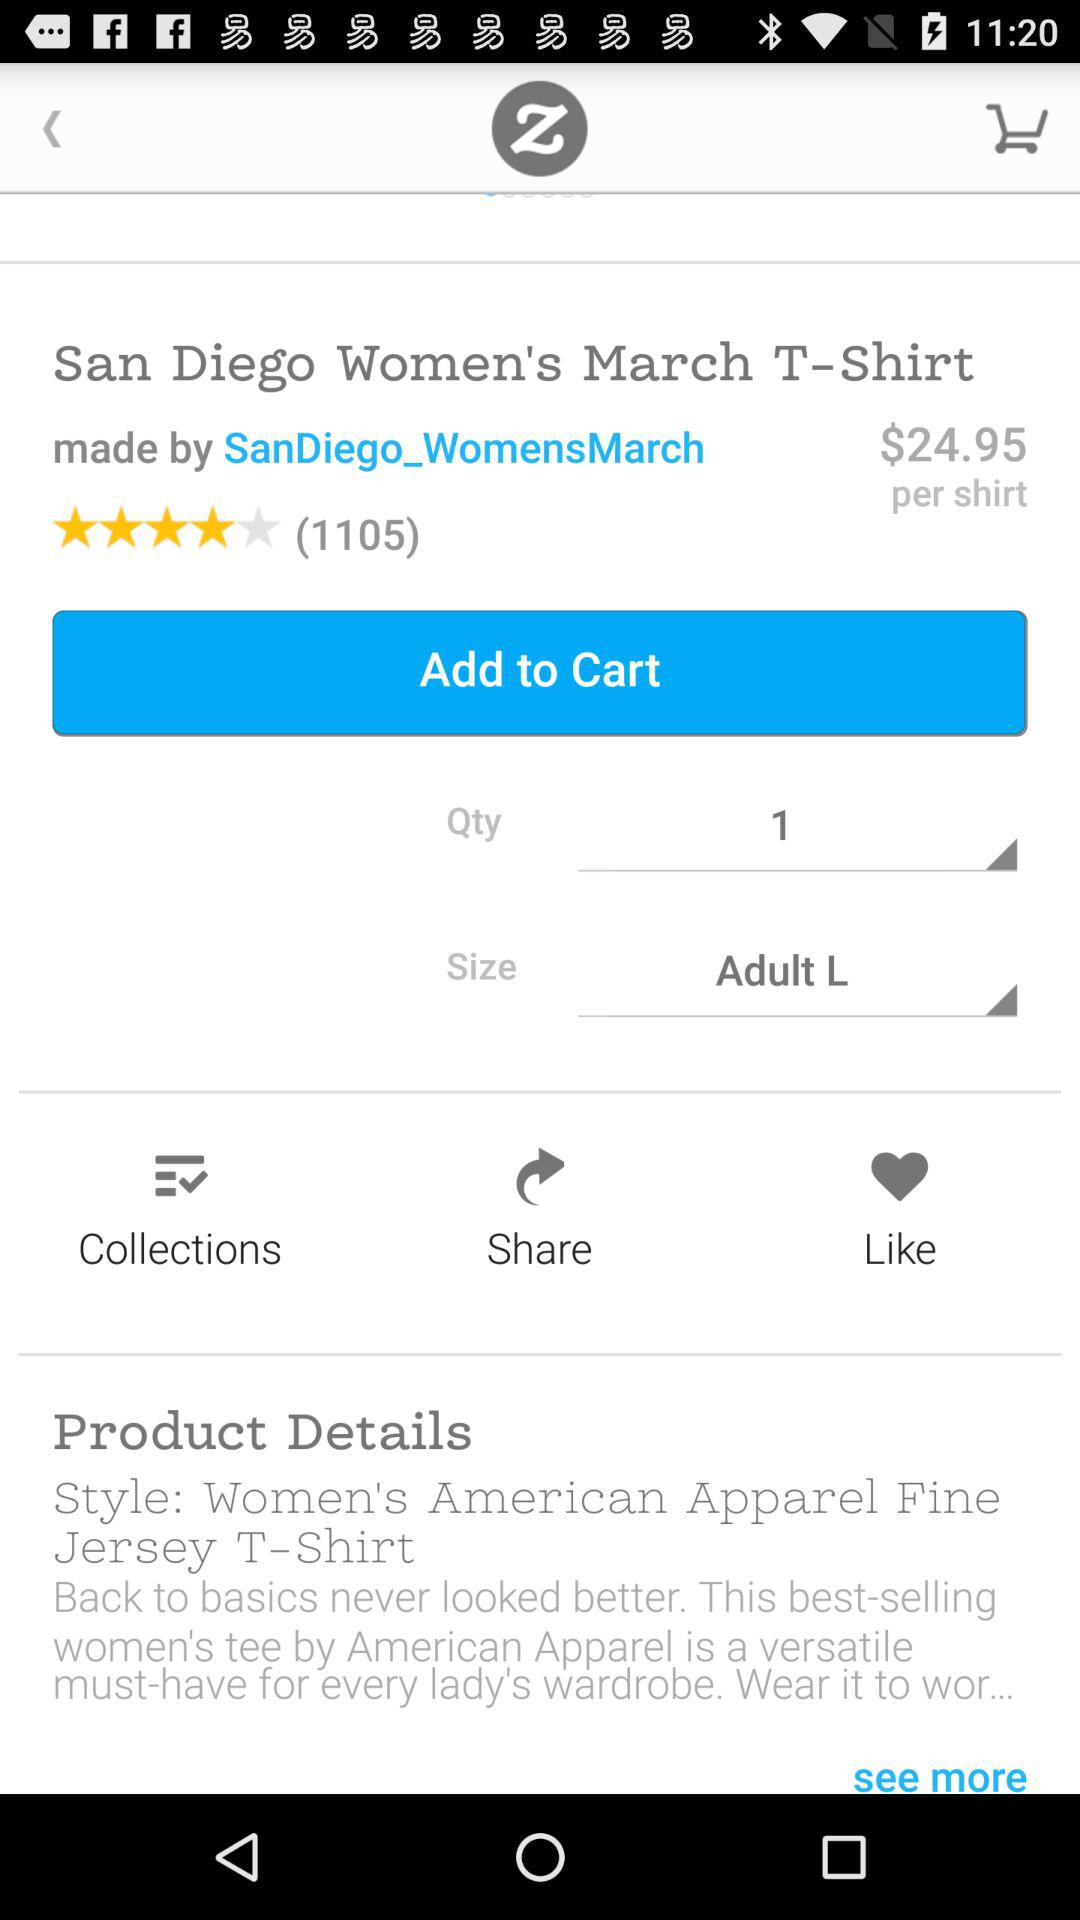What is the price of San Diego Women's March T-Shirt? The price of San Diego Women's March T-Shirt is $24.95 per shirt. 